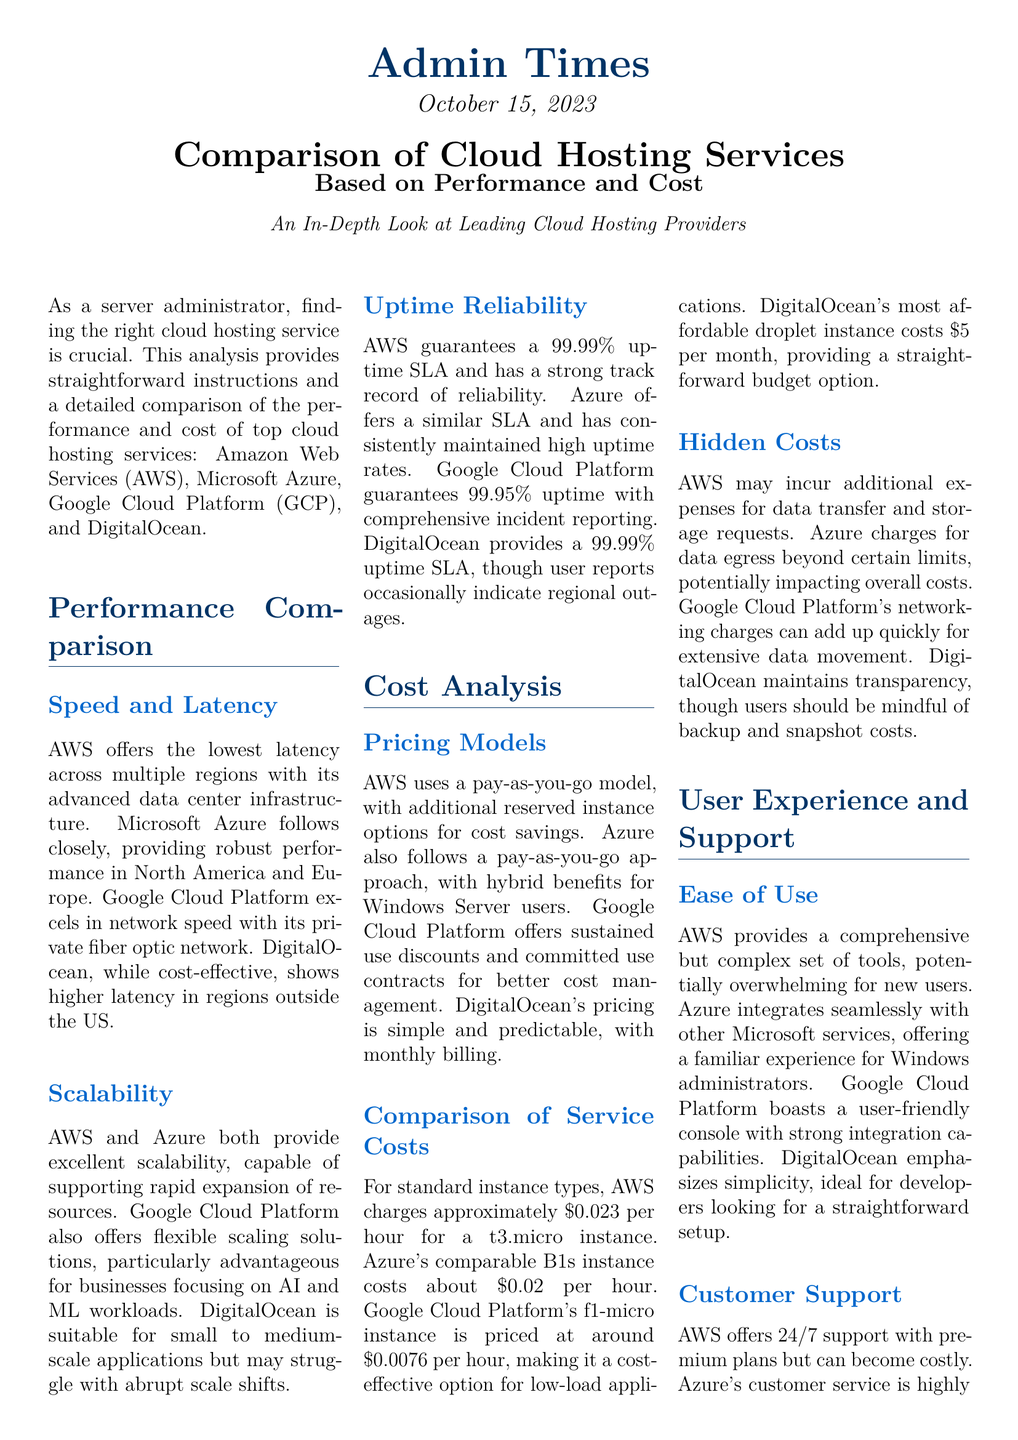What is the publication date of the document? The publication date is mentioned in the document as October 15, 2023.
Answer: October 15, 2023 Which cloud service provider guarantees a 99.99% uptime SLA? AWS and DigitalOcean both guarantee a 99.99% uptime SLA, as stated in the uptime reliability section.
Answer: AWS and DigitalOcean What is the cost per hour for Google's f1-micro instance? The f1-micro instance is priced at around $0.0076 per hour, according to the service costs comparison.
Answer: $0.0076 Which cloud hosting service is described as emphasizing simplicity? DigitalOcean emphasizes simplicity in its user experience section, targeting developers.
Answer: DigitalOcean What pricing model does AWS utilize? AWS uses a pay-as-you-go model, as detailed in the pricing models section.
Answer: Pay-as-you-go model How does Azure's pricing for B1s instance compare to AWS's t3.micro instance? Azure's B1s instance costs about $0.02 per hour, which is slightly lower than AWS's cost, which is approximately $0.023 per hour.
Answer: $0.02 per hour Which cloud service provider is ideal for developers looking for straightforward setup? DigitalOcean is highlighted as ideal for developers looking for a straightforward setup.
Answer: DigitalOcean What type of support does AWS offer? AWS offers 24/7 support, as noted in the customer support section of the document.
Answer: 24/7 support 